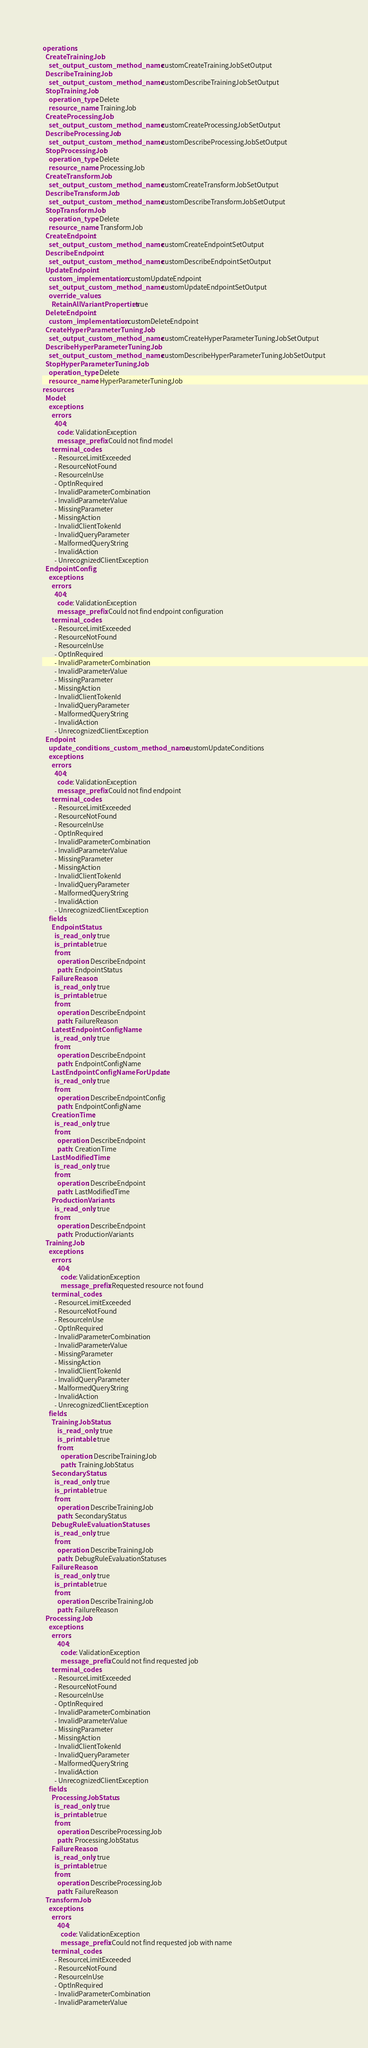<code> <loc_0><loc_0><loc_500><loc_500><_YAML_>operations:
  CreateTrainingJob:
    set_output_custom_method_name: customCreateTrainingJobSetOutput
  DescribeTrainingJob:
    set_output_custom_method_name: customDescribeTrainingJobSetOutput
  StopTrainingJob:
    operation_type: Delete
    resource_name: TrainingJob
  CreateProcessingJob:
    set_output_custom_method_name: customCreateProcessingJobSetOutput
  DescribeProcessingJob:
    set_output_custom_method_name: customDescribeProcessingJobSetOutput
  StopProcessingJob:
    operation_type: Delete
    resource_name: ProcessingJob
  CreateTransformJob:
    set_output_custom_method_name: customCreateTransformJobSetOutput
  DescribeTransformJob:
    set_output_custom_method_name: customDescribeTransformJobSetOutput
  StopTransformJob:
    operation_type: Delete
    resource_name: TransformJob
  CreateEndpoint:
    set_output_custom_method_name: customCreateEndpointSetOutput
  DescribeEndpoint:
    set_output_custom_method_name: customDescribeEndpointSetOutput
  UpdateEndpoint:
    custom_implementation: customUpdateEndpoint
    set_output_custom_method_name: customUpdateEndpointSetOutput
    override_values:
      RetainAllVariantProperties: true
  DeleteEndpoint:
    custom_implementation: customDeleteEndpoint
  CreateHyperParameterTuningJob:
    set_output_custom_method_name: customCreateHyperParameterTuningJobSetOutput
  DescribeHyperParameterTuningJob:
    set_output_custom_method_name: customDescribeHyperParameterTuningJobSetOutput
  StopHyperParameterTuningJob:
    operation_type: Delete
    resource_name: HyperParameterTuningJob
resources:
  Model:
    exceptions:
      errors:
        404:
          code: ValidationException
          message_prefix: Could not find model
      terminal_codes:
        - ResourceLimitExceeded
        - ResourceNotFound
        - ResourceInUse
        - OptInRequired
        - InvalidParameterCombination
        - InvalidParameterValue
        - MissingParameter
        - MissingAction
        - InvalidClientTokenId
        - InvalidQueryParameter
        - MalformedQueryString
        - InvalidAction
        - UnrecognizedClientException
  EndpointConfig:
    exceptions:
      errors:
        404:
          code: ValidationException
          message_prefix: Could not find endpoint configuration
      terminal_codes:
        - ResourceLimitExceeded
        - ResourceNotFound
        - ResourceInUse
        - OptInRequired
        - InvalidParameterCombination
        - InvalidParameterValue
        - MissingParameter
        - MissingAction
        - InvalidClientTokenId
        - InvalidQueryParameter
        - MalformedQueryString
        - InvalidAction
        - UnrecognizedClientException
  Endpoint:
    update_conditions_custom_method_name: customUpdateConditions
    exceptions:
      errors:
        404:
          code: ValidationException
          message_prefix: Could not find endpoint
      terminal_codes:
        - ResourceLimitExceeded
        - ResourceNotFound
        - ResourceInUse
        - OptInRequired
        - InvalidParameterCombination
        - InvalidParameterValue
        - MissingParameter
        - MissingAction
        - InvalidClientTokenId
        - InvalidQueryParameter
        - MalformedQueryString
        - InvalidAction
        - UnrecognizedClientException
    fields:
      EndpointStatus:
        is_read_only: true
        is_printable: true
        from:
          operation: DescribeEndpoint
          path: EndpointStatus
      FailureReason:
        is_read_only: true
        is_printable: true
        from:
          operation: DescribeEndpoint
          path: FailureReason
      LatestEndpointConfigName:
        is_read_only: true
        from:
          operation: DescribeEndpoint
          path: EndpointConfigName
      LastEndpointConfigNameForUpdate:
        is_read_only: true
        from:
          operation: DescribeEndpointConfig
          path: EndpointConfigName
      CreationTime:
        is_read_only: true
        from:
          operation: DescribeEndpoint
          path: CreationTime
      LastModifiedTime:
        is_read_only: true
        from:
          operation: DescribeEndpoint
          path: LastModifiedTime
      ProductionVariants:
        is_read_only: true
        from:
          operation: DescribeEndpoint
          path: ProductionVariants
  TrainingJob:
    exceptions:
      errors:
          404:
            code: ValidationException
            message_prefix: Requested resource not found
      terminal_codes:
        - ResourceLimitExceeded
        - ResourceNotFound
        - ResourceInUse
        - OptInRequired
        - InvalidParameterCombination
        - InvalidParameterValue
        - MissingParameter
        - MissingAction
        - InvalidClientTokenId
        - InvalidQueryParameter
        - MalformedQueryString
        - InvalidAction
        - UnrecognizedClientException
    fields:
      TrainingJobStatus:
          is_read_only: true
          is_printable: true
          from:
            operation: DescribeTrainingJob
            path: TrainingJobStatus
      SecondaryStatus:
        is_read_only: true
        is_printable: true
        from:
          operation: DescribeTrainingJob
          path: SecondaryStatus
      DebugRuleEvaluationStatuses:
        is_read_only: true
        from:
          operation: DescribeTrainingJob
          path: DebugRuleEvaluationStatuses 
      FailureReason:
        is_read_only: true
        is_printable: true
        from:
          operation: DescribeTrainingJob
          path: FailureReason 
  ProcessingJob:
    exceptions:
      errors:
          404:
            code: ValidationException
            message_prefix: Could not find requested job
      terminal_codes:
        - ResourceLimitExceeded
        - ResourceNotFound
        - ResourceInUse
        - OptInRequired
        - InvalidParameterCombination
        - InvalidParameterValue
        - MissingParameter
        - MissingAction
        - InvalidClientTokenId
        - InvalidQueryParameter
        - MalformedQueryString
        - InvalidAction
        - UnrecognizedClientException
    fields:
      ProcessingJobStatus:
        is_read_only: true
        is_printable: true
        from:
          operation: DescribeProcessingJob
          path: ProcessingJobStatus
      FailureReason:
        is_read_only: true
        is_printable: true
        from:
          operation: DescribeProcessingJob
          path: FailureReason 
  TransformJob:
    exceptions:
      errors:
          404:
            code: ValidationException
            message_prefix: Could not find requested job with name
      terminal_codes:
        - ResourceLimitExceeded
        - ResourceNotFound
        - ResourceInUse
        - OptInRequired
        - InvalidParameterCombination
        - InvalidParameterValue</code> 